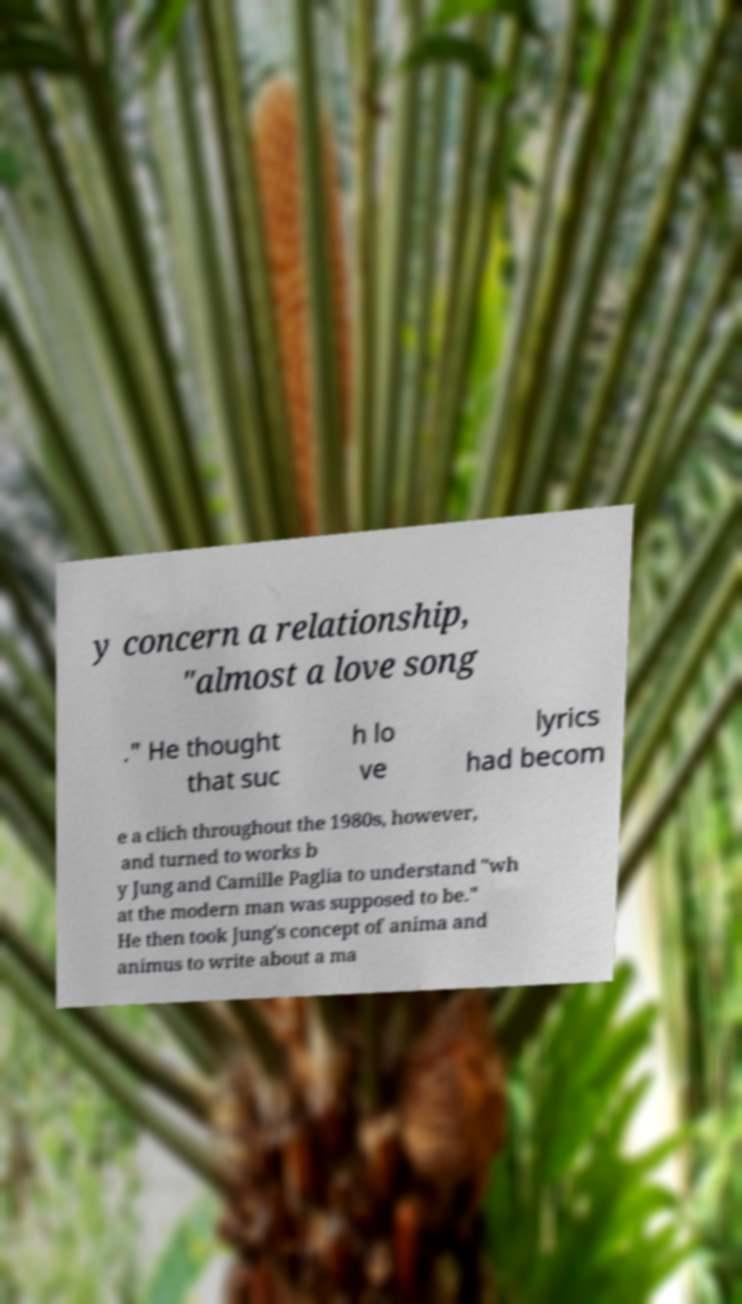Please identify and transcribe the text found in this image. y concern a relationship, "almost a love song ." He thought that suc h lo ve lyrics had becom e a clich throughout the 1980s, however, and turned to works b y Jung and Camille Paglia to understand "wh at the modern man was supposed to be." He then took Jung's concept of anima and animus to write about a ma 